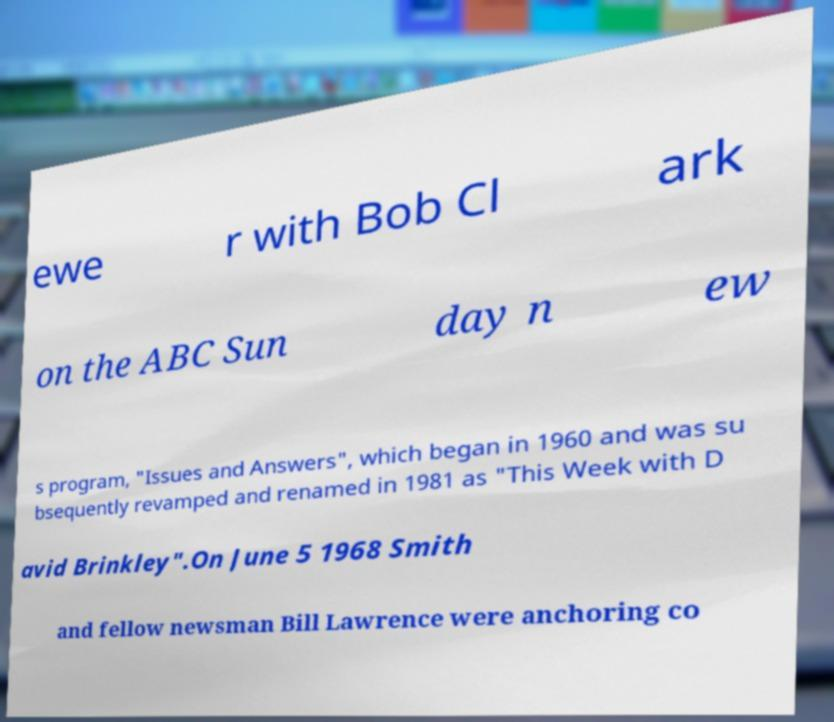Please read and relay the text visible in this image. What does it say? ewe r with Bob Cl ark on the ABC Sun day n ew s program, "Issues and Answers", which began in 1960 and was su bsequently revamped and renamed in 1981 as "This Week with D avid Brinkley".On June 5 1968 Smith and fellow newsman Bill Lawrence were anchoring co 